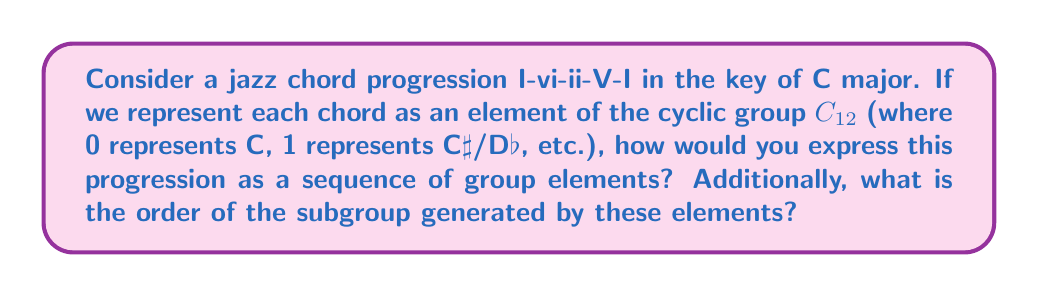Teach me how to tackle this problem. Let's approach this step-by-step:

1) First, we need to map the chords to elements in $C_{12}$:
   I (C major) = 0
   vi (A minor) = 9
   ii (D minor) = 2
   V (G major) = 7

2) So, our chord progression I-vi-ii-V-I becomes the sequence:
   $$(0, 9, 2, 7, 0)$$

3) To find the order of the subgroup generated by these elements, we need to consider the distinct elements:
   $\{0, 9, 2, 7\}$

4) We can represent this as a set $S = \{0, 2, 7, 9\}$

5) The subgroup generated by $S$ is $\langle S \rangle = \{n_1 \cdot 0 + n_2 \cdot 2 + n_3 \cdot 7 + n_4 \cdot 9 \pmod{12} : n_i \in \mathbb{Z}\}$

6) We can simplify this further:
   $\langle S \rangle = \{(2n_2 + 7n_3 + 9n_4) \pmod{12} : n_i \in \mathbb{Z}\}$

7) The greatest common divisor of 2, 7, 9, and 12 is 1, which means that this subgroup generates all elements of $C_{12}$.

8) Therefore, the order of the subgroup is 12, which is the same as the order of $C_{12}$.

This result aligns with the jazz musician's understanding that all 12 tones are accessible within a progression, reflecting the rich harmonic possibilities in jazz music.
Answer: $(0, 9, 2, 7, 0)$; Order: 12 